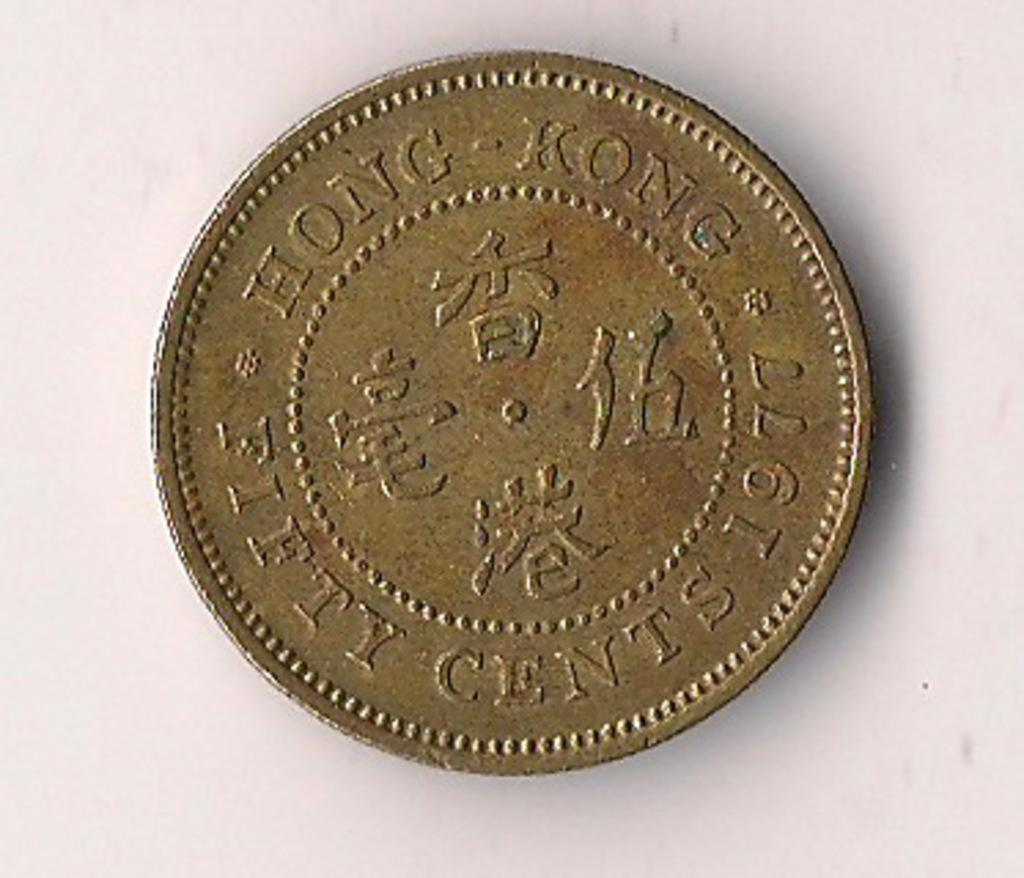What is the main subject of the image? There is a coin in the center of the image. Can you describe the background of the image? There is a wall in the background of the image. Who is the creator of the hammer seen in the image? There is no hammer present in the image. 